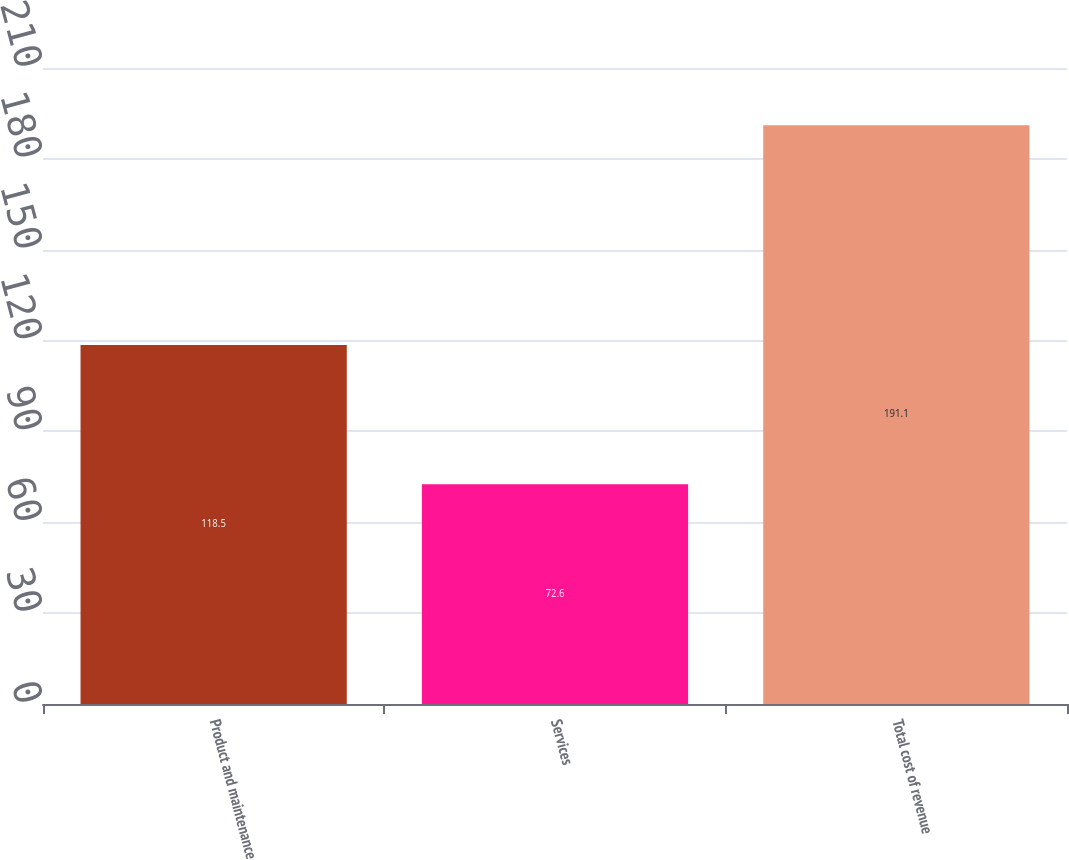Convert chart to OTSL. <chart><loc_0><loc_0><loc_500><loc_500><bar_chart><fcel>Product and maintenance<fcel>Services<fcel>Total cost of revenue<nl><fcel>118.5<fcel>72.6<fcel>191.1<nl></chart> 